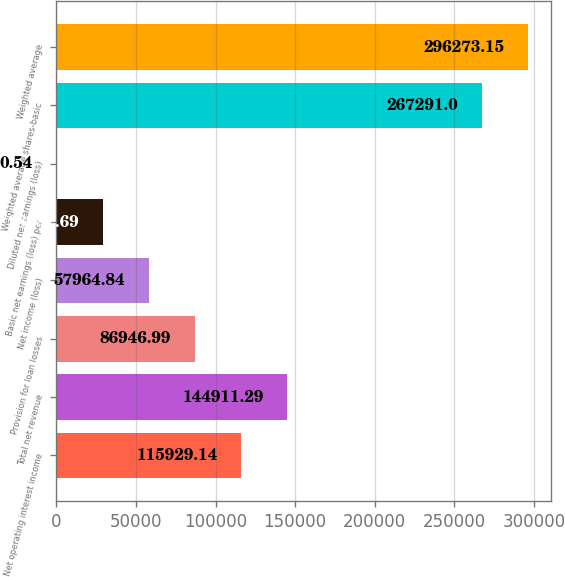Convert chart. <chart><loc_0><loc_0><loc_500><loc_500><bar_chart><fcel>Net operating interest income<fcel>Total net revenue<fcel>Provision for loan losses<fcel>Net income (loss)<fcel>Basic net earnings (loss) per<fcel>Diluted net earnings (loss)<fcel>Weighted average shares-basic<fcel>Weighted average<nl><fcel>115929<fcel>144911<fcel>86947<fcel>57964.8<fcel>28982.7<fcel>0.54<fcel>267291<fcel>296273<nl></chart> 